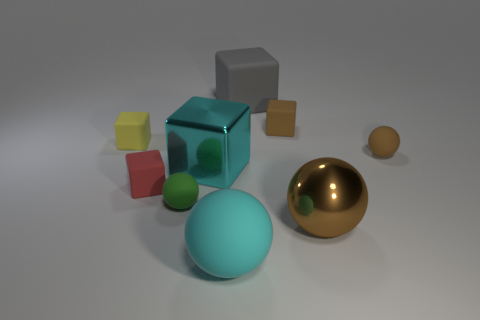What number of small things are both to the right of the big brown metallic ball and behind the tiny yellow block?
Provide a succinct answer. 0. Are there an equal number of large balls behind the small green matte sphere and tiny brown matte things in front of the large brown metal sphere?
Your answer should be very brief. Yes. There is a big metal thing that is right of the big gray thing; is it the same shape as the green rubber thing?
Your answer should be very brief. Yes. There is a brown thing on the left side of the brown thing that is in front of the tiny brown matte thing that is in front of the yellow object; what is its shape?
Your answer should be compact. Cube. There is a metallic thing that is the same color as the large rubber sphere; what is its shape?
Offer a very short reply. Cube. What is the material of the sphere that is in front of the small green thing and behind the cyan matte sphere?
Ensure brevity in your answer.  Metal. Are there fewer big cyan things than tiny green objects?
Make the answer very short. No. Do the brown shiny object and the large rubber thing that is in front of the large gray rubber object have the same shape?
Provide a short and direct response. Yes. There is a rubber sphere behind the red rubber object; is its size the same as the green matte sphere?
Your answer should be very brief. Yes. The brown object that is the same size as the gray cube is what shape?
Ensure brevity in your answer.  Sphere. 